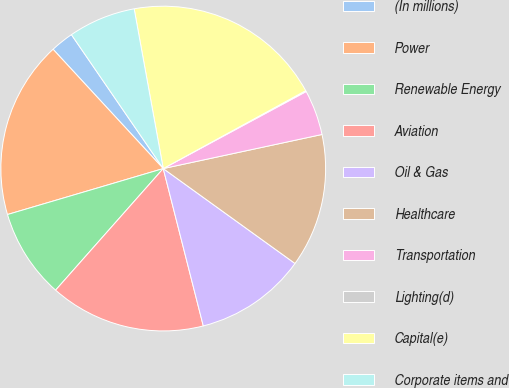Convert chart. <chart><loc_0><loc_0><loc_500><loc_500><pie_chart><fcel>(In millions)<fcel>Power<fcel>Renewable Energy<fcel>Aviation<fcel>Oil & Gas<fcel>Healthcare<fcel>Transportation<fcel>Lighting(d)<fcel>Capital(e)<fcel>Corporate items and<nl><fcel>2.3%<fcel>17.7%<fcel>8.9%<fcel>15.5%<fcel>11.1%<fcel>13.3%<fcel>4.5%<fcel>0.1%<fcel>19.9%<fcel>6.7%<nl></chart> 